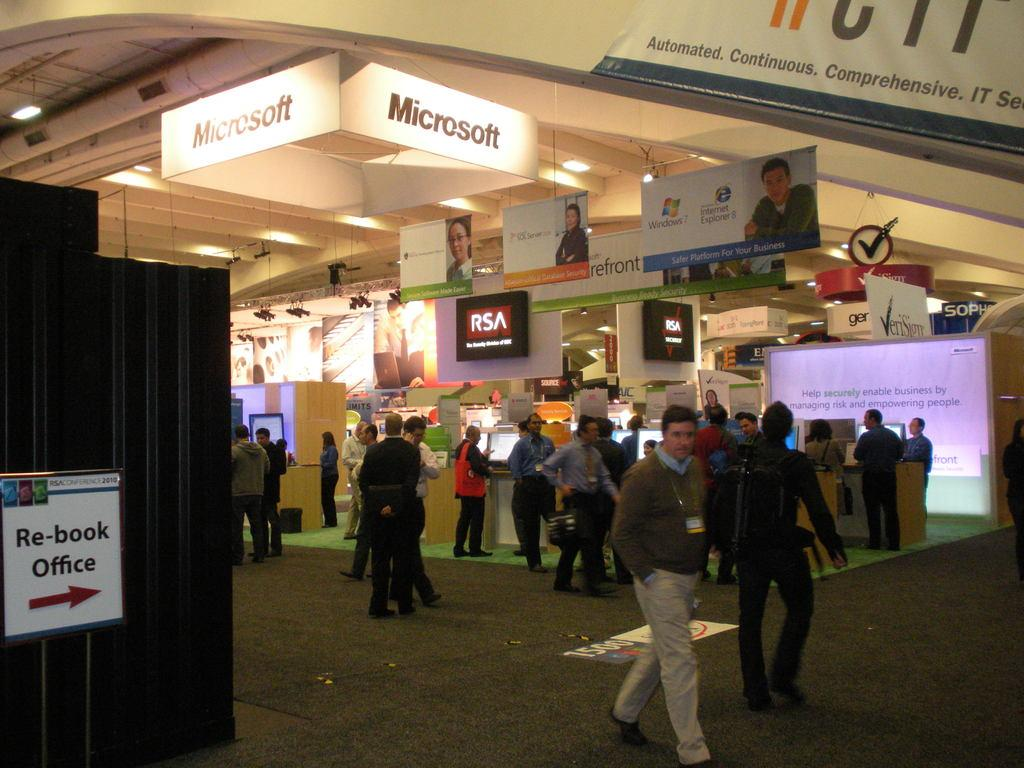How many persons can be seen standing in the image? There are few persons standing in the image. What can be seen in the background of the image? There are stores visible in the background of the image. What type of marble is visible on the floor in the image? There is no marble visible on the floor in the image. What team is playing in the image? There is no team playing in the image. What type of farm is present in the image? There is no farm present in the image. 